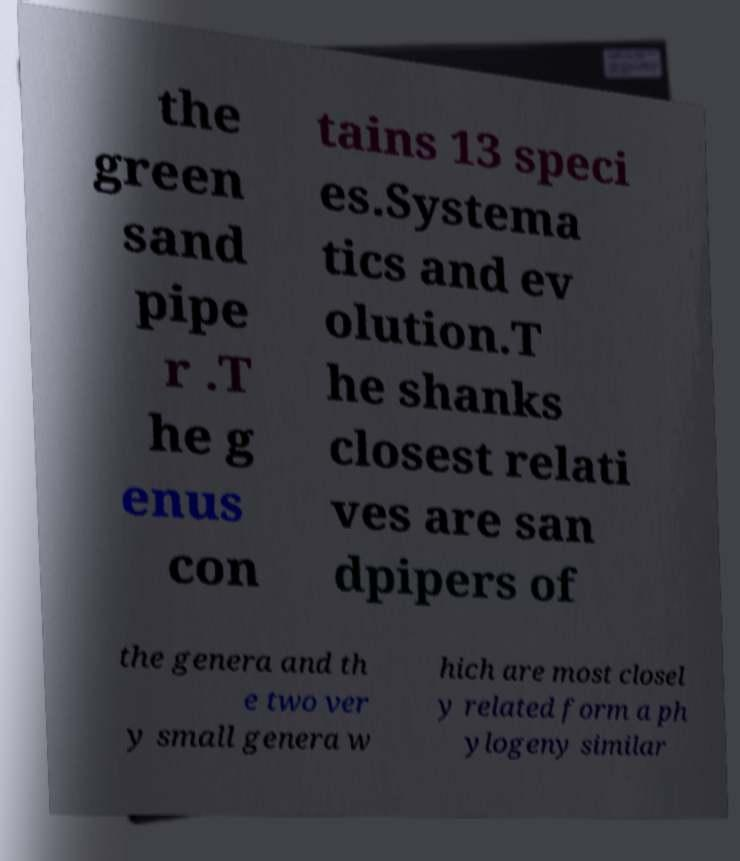There's text embedded in this image that I need extracted. Can you transcribe it verbatim? the green sand pipe r .T he g enus con tains 13 speci es.Systema tics and ev olution.T he shanks closest relati ves are san dpipers of the genera and th e two ver y small genera w hich are most closel y related form a ph ylogeny similar 